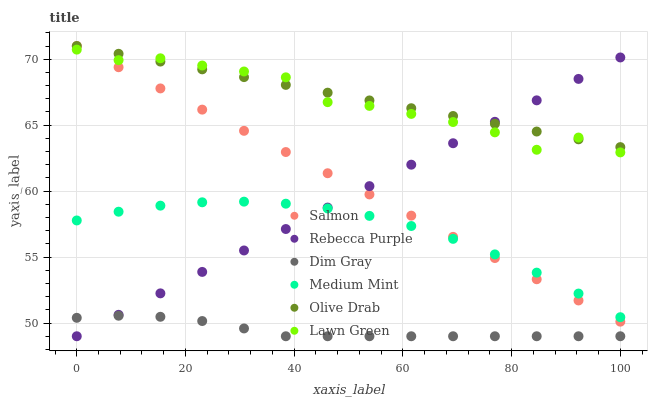Does Dim Gray have the minimum area under the curve?
Answer yes or no. Yes. Does Olive Drab have the maximum area under the curve?
Answer yes or no. Yes. Does Lawn Green have the minimum area under the curve?
Answer yes or no. No. Does Lawn Green have the maximum area under the curve?
Answer yes or no. No. Is Rebecca Purple the smoothest?
Answer yes or no. Yes. Is Lawn Green the roughest?
Answer yes or no. Yes. Is Dim Gray the smoothest?
Answer yes or no. No. Is Dim Gray the roughest?
Answer yes or no. No. Does Dim Gray have the lowest value?
Answer yes or no. Yes. Does Lawn Green have the lowest value?
Answer yes or no. No. Does Olive Drab have the highest value?
Answer yes or no. Yes. Does Lawn Green have the highest value?
Answer yes or no. No. Is Medium Mint less than Lawn Green?
Answer yes or no. Yes. Is Lawn Green greater than Medium Mint?
Answer yes or no. Yes. Does Rebecca Purple intersect Lawn Green?
Answer yes or no. Yes. Is Rebecca Purple less than Lawn Green?
Answer yes or no. No. Is Rebecca Purple greater than Lawn Green?
Answer yes or no. No. Does Medium Mint intersect Lawn Green?
Answer yes or no. No. 